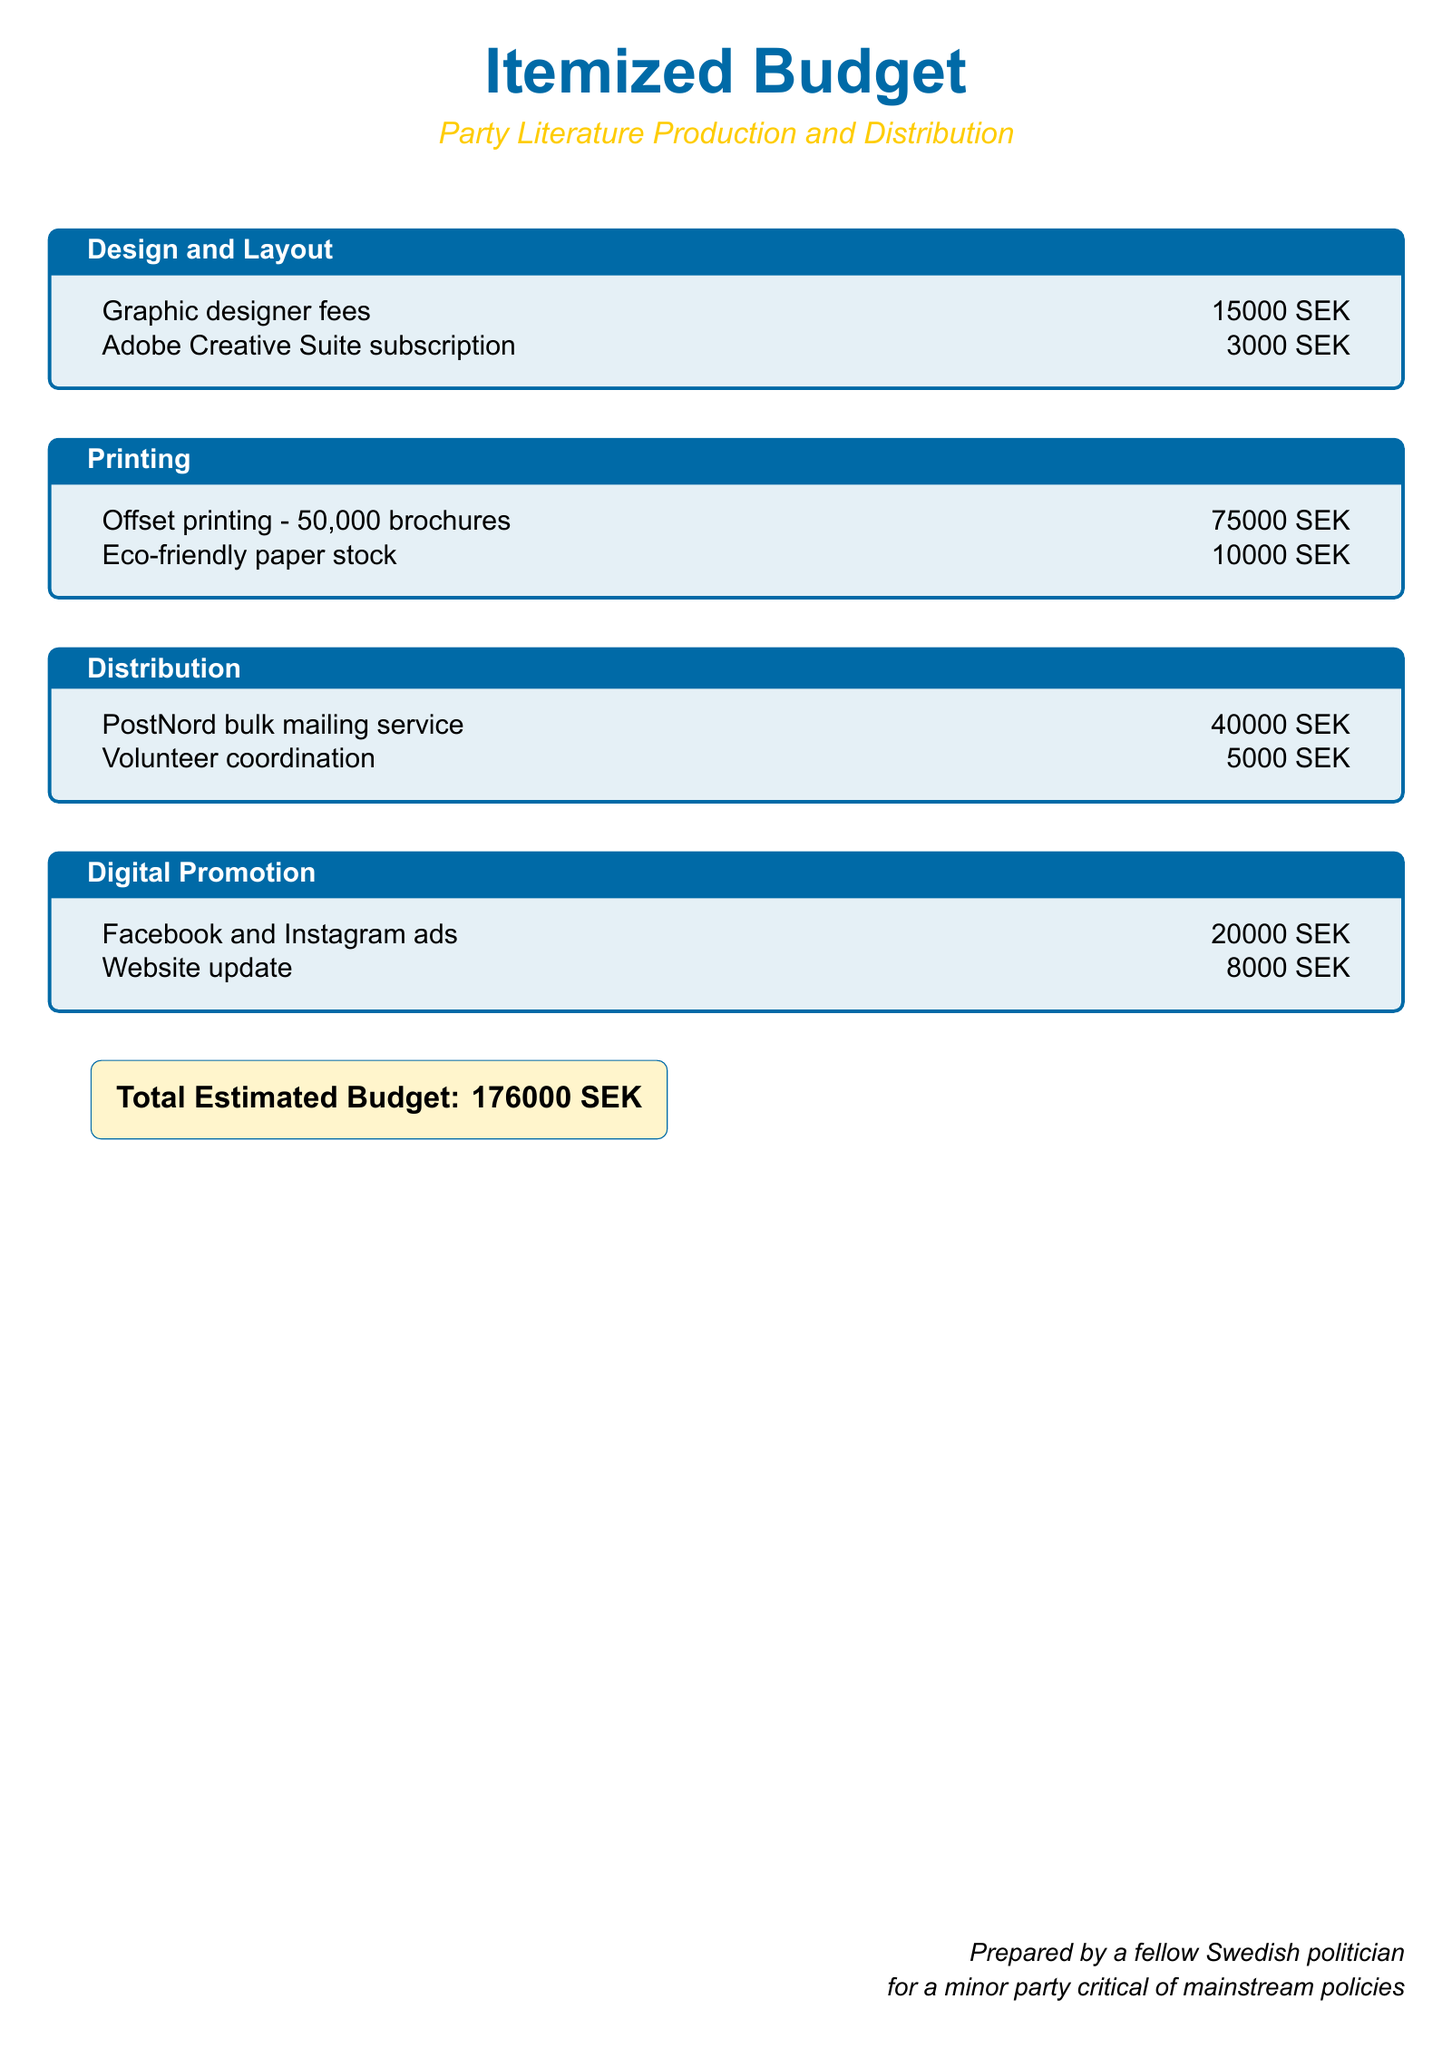What is the total estimated budget? The total estimated budget is clearly stated at the bottom of the document, summarizing all expenses.
Answer: 176000 SEK How much is allocated for graphic designer fees? The document specifies the fee for graphic designer services under the Design and Layout section.
Answer: 15000 SEK What type of paper stock is used for printing? The document mentions that eco-friendly paper stock is chosen for the production of brochures in the Printing section.
Answer: Eco-friendly paper stock How much will it cost to update the website? The budget outlines the cost for website updates under the Digital Promotion section.
Answer: 8000 SEK What is the cost of the PostNord bulk mailing service? The amount allocated for the PostNord bulk mailing service is indicated in the Distribution section of the budget.
Answer: 40000 SEK How much is budgeted for Facebook and Instagram ads? The document provides the budgeted amount for social media advertising, which falls under Digital Promotion.
Answer: 20000 SEK Which service incurs a fee of 5000 SEK? The cost of 5000 SEK is for volunteer coordination, mentioned in the Distribution section of the document.
Answer: Volunteer coordination What subscription is included in the design costs? The budget lists the Adobe Creative Suite subscription under the Design and Layout expenses.
Answer: Adobe Creative Suite subscription 